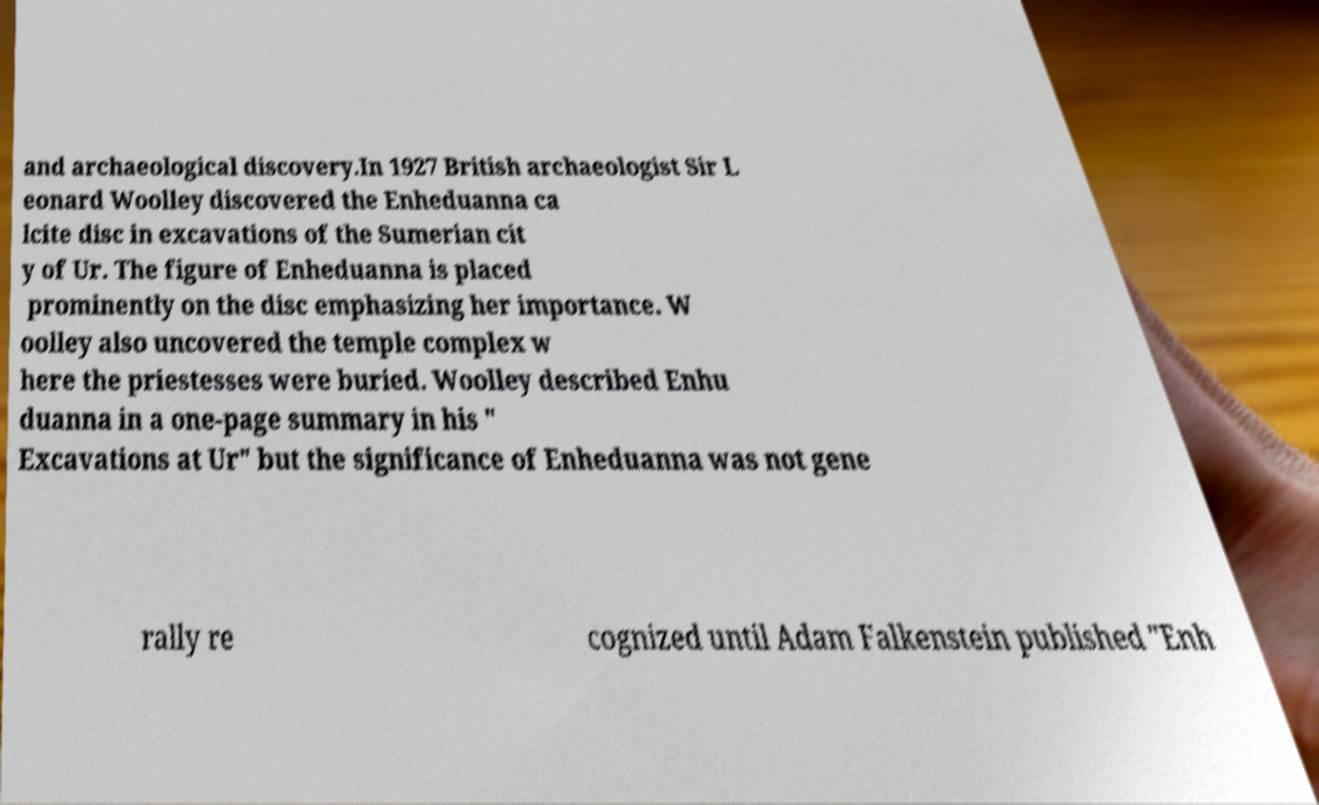Please read and relay the text visible in this image. What does it say? and archaeological discovery.In 1927 British archaeologist Sir L eonard Woolley discovered the Enheduanna ca lcite disc in excavations of the Sumerian cit y of Ur. The figure of Enheduanna is placed prominently on the disc emphasizing her importance. W oolley also uncovered the temple complex w here the priestesses were buried. Woolley described Enhu duanna in a one-page summary in his " Excavations at Ur" but the significance of Enheduanna was not gene rally re cognized until Adam Falkenstein published "Enh 